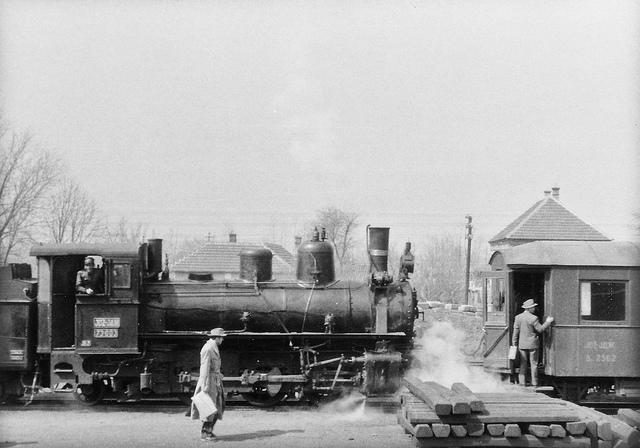Is this a professional picture?
Be succinct. No. Where was the picture taken from?
Write a very short answer. Train station. What color is the train near the passengers?
Answer briefly. Black. Is there a skyscraper in the scene?
Keep it brief. No. Are they at a party station?
Keep it brief. No. What color is the train engine?
Write a very short answer. Black. How many people are there?
Concise answer only. 3. Is it dark here?
Keep it brief. No. 